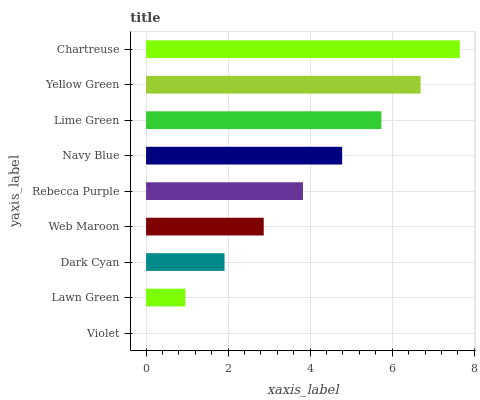Is Violet the minimum?
Answer yes or no. Yes. Is Chartreuse the maximum?
Answer yes or no. Yes. Is Lawn Green the minimum?
Answer yes or no. No. Is Lawn Green the maximum?
Answer yes or no. No. Is Lawn Green greater than Violet?
Answer yes or no. Yes. Is Violet less than Lawn Green?
Answer yes or no. Yes. Is Violet greater than Lawn Green?
Answer yes or no. No. Is Lawn Green less than Violet?
Answer yes or no. No. Is Rebecca Purple the high median?
Answer yes or no. Yes. Is Rebecca Purple the low median?
Answer yes or no. Yes. Is Web Maroon the high median?
Answer yes or no. No. Is Dark Cyan the low median?
Answer yes or no. No. 